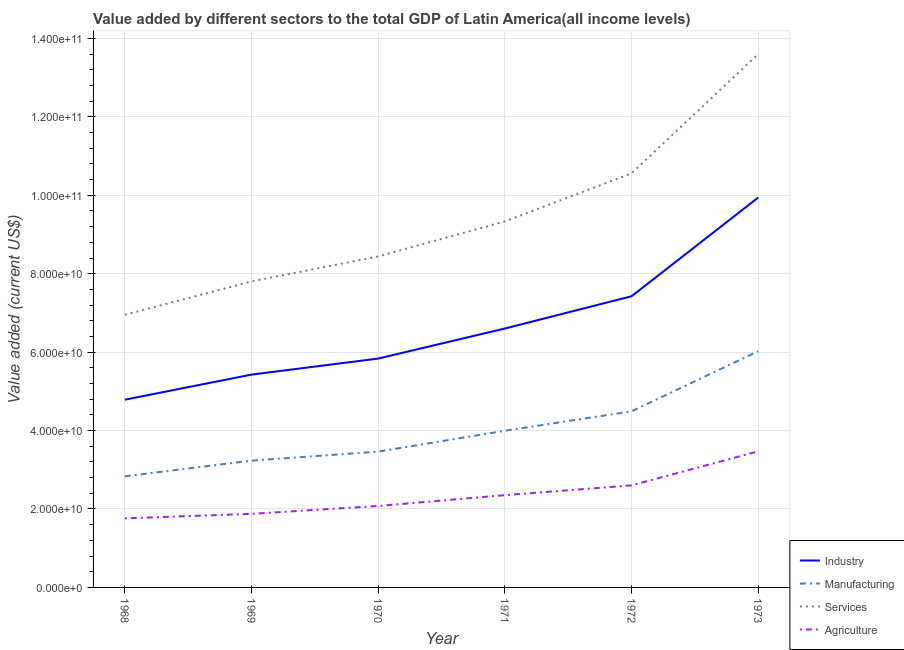How many different coloured lines are there?
Make the answer very short. 4. What is the value added by manufacturing sector in 1972?
Your answer should be very brief. 4.49e+1. Across all years, what is the maximum value added by services sector?
Provide a succinct answer. 1.36e+11. Across all years, what is the minimum value added by manufacturing sector?
Make the answer very short. 2.83e+1. In which year was the value added by agricultural sector minimum?
Make the answer very short. 1968. What is the total value added by services sector in the graph?
Ensure brevity in your answer.  5.67e+11. What is the difference between the value added by industrial sector in 1969 and that in 1971?
Provide a short and direct response. -1.18e+1. What is the difference between the value added by industrial sector in 1971 and the value added by services sector in 1970?
Make the answer very short. -1.84e+1. What is the average value added by manufacturing sector per year?
Make the answer very short. 4.01e+1. In the year 1970, what is the difference between the value added by agricultural sector and value added by manufacturing sector?
Offer a terse response. -1.39e+1. In how many years, is the value added by services sector greater than 88000000000 US$?
Your answer should be compact. 3. What is the ratio of the value added by manufacturing sector in 1968 to that in 1971?
Provide a short and direct response. 0.71. Is the value added by services sector in 1972 less than that in 1973?
Offer a very short reply. Yes. Is the difference between the value added by industrial sector in 1972 and 1973 greater than the difference between the value added by services sector in 1972 and 1973?
Provide a succinct answer. Yes. What is the difference between the highest and the second highest value added by manufacturing sector?
Make the answer very short. 1.53e+1. What is the difference between the highest and the lowest value added by agricultural sector?
Provide a succinct answer. 1.71e+1. In how many years, is the value added by manufacturing sector greater than the average value added by manufacturing sector taken over all years?
Ensure brevity in your answer.  2. Is the sum of the value added by manufacturing sector in 1971 and 1973 greater than the maximum value added by agricultural sector across all years?
Provide a short and direct response. Yes. Is it the case that in every year, the sum of the value added by services sector and value added by manufacturing sector is greater than the sum of value added by agricultural sector and value added by industrial sector?
Provide a short and direct response. No. Does the value added by manufacturing sector monotonically increase over the years?
Make the answer very short. Yes. How many years are there in the graph?
Offer a very short reply. 6. How many legend labels are there?
Provide a succinct answer. 4. What is the title of the graph?
Keep it short and to the point. Value added by different sectors to the total GDP of Latin America(all income levels). What is the label or title of the X-axis?
Provide a succinct answer. Year. What is the label or title of the Y-axis?
Your answer should be very brief. Value added (current US$). What is the Value added (current US$) in Industry in 1968?
Ensure brevity in your answer.  4.79e+1. What is the Value added (current US$) of Manufacturing in 1968?
Offer a very short reply. 2.83e+1. What is the Value added (current US$) in Services in 1968?
Provide a succinct answer. 6.95e+1. What is the Value added (current US$) of Agriculture in 1968?
Keep it short and to the point. 1.76e+1. What is the Value added (current US$) in Industry in 1969?
Your answer should be very brief. 5.43e+1. What is the Value added (current US$) in Manufacturing in 1969?
Provide a succinct answer. 3.23e+1. What is the Value added (current US$) in Services in 1969?
Provide a succinct answer. 7.80e+1. What is the Value added (current US$) in Agriculture in 1969?
Give a very brief answer. 1.88e+1. What is the Value added (current US$) in Industry in 1970?
Your response must be concise. 5.84e+1. What is the Value added (current US$) in Manufacturing in 1970?
Keep it short and to the point. 3.46e+1. What is the Value added (current US$) of Services in 1970?
Provide a short and direct response. 8.44e+1. What is the Value added (current US$) in Agriculture in 1970?
Provide a short and direct response. 2.08e+1. What is the Value added (current US$) of Industry in 1971?
Give a very brief answer. 6.60e+1. What is the Value added (current US$) in Manufacturing in 1971?
Provide a short and direct response. 3.99e+1. What is the Value added (current US$) of Services in 1971?
Your answer should be compact. 9.33e+1. What is the Value added (current US$) in Agriculture in 1971?
Make the answer very short. 2.35e+1. What is the Value added (current US$) in Industry in 1972?
Your response must be concise. 7.42e+1. What is the Value added (current US$) of Manufacturing in 1972?
Offer a terse response. 4.49e+1. What is the Value added (current US$) of Services in 1972?
Provide a short and direct response. 1.06e+11. What is the Value added (current US$) in Agriculture in 1972?
Offer a very short reply. 2.60e+1. What is the Value added (current US$) in Industry in 1973?
Give a very brief answer. 9.94e+1. What is the Value added (current US$) in Manufacturing in 1973?
Your answer should be very brief. 6.02e+1. What is the Value added (current US$) of Services in 1973?
Your answer should be compact. 1.36e+11. What is the Value added (current US$) of Agriculture in 1973?
Ensure brevity in your answer.  3.47e+1. Across all years, what is the maximum Value added (current US$) in Industry?
Your response must be concise. 9.94e+1. Across all years, what is the maximum Value added (current US$) of Manufacturing?
Keep it short and to the point. 6.02e+1. Across all years, what is the maximum Value added (current US$) of Services?
Your answer should be very brief. 1.36e+11. Across all years, what is the maximum Value added (current US$) in Agriculture?
Give a very brief answer. 3.47e+1. Across all years, what is the minimum Value added (current US$) of Industry?
Offer a terse response. 4.79e+1. Across all years, what is the minimum Value added (current US$) of Manufacturing?
Ensure brevity in your answer.  2.83e+1. Across all years, what is the minimum Value added (current US$) in Services?
Your response must be concise. 6.95e+1. Across all years, what is the minimum Value added (current US$) of Agriculture?
Provide a succinct answer. 1.76e+1. What is the total Value added (current US$) in Industry in the graph?
Your answer should be very brief. 4.00e+11. What is the total Value added (current US$) in Manufacturing in the graph?
Your response must be concise. 2.40e+11. What is the total Value added (current US$) of Services in the graph?
Offer a very short reply. 5.67e+11. What is the total Value added (current US$) of Agriculture in the graph?
Your answer should be compact. 1.41e+11. What is the difference between the Value added (current US$) in Industry in 1968 and that in 1969?
Give a very brief answer. -6.40e+09. What is the difference between the Value added (current US$) in Manufacturing in 1968 and that in 1969?
Give a very brief answer. -4.00e+09. What is the difference between the Value added (current US$) in Services in 1968 and that in 1969?
Offer a terse response. -8.50e+09. What is the difference between the Value added (current US$) of Agriculture in 1968 and that in 1969?
Make the answer very short. -1.15e+09. What is the difference between the Value added (current US$) in Industry in 1968 and that in 1970?
Ensure brevity in your answer.  -1.05e+1. What is the difference between the Value added (current US$) in Manufacturing in 1968 and that in 1970?
Give a very brief answer. -6.30e+09. What is the difference between the Value added (current US$) of Services in 1968 and that in 1970?
Keep it short and to the point. -1.49e+1. What is the difference between the Value added (current US$) in Agriculture in 1968 and that in 1970?
Your answer should be compact. -3.16e+09. What is the difference between the Value added (current US$) in Industry in 1968 and that in 1971?
Your answer should be compact. -1.82e+1. What is the difference between the Value added (current US$) in Manufacturing in 1968 and that in 1971?
Give a very brief answer. -1.16e+1. What is the difference between the Value added (current US$) of Services in 1968 and that in 1971?
Provide a short and direct response. -2.38e+1. What is the difference between the Value added (current US$) of Agriculture in 1968 and that in 1971?
Give a very brief answer. -5.92e+09. What is the difference between the Value added (current US$) in Industry in 1968 and that in 1972?
Keep it short and to the point. -2.64e+1. What is the difference between the Value added (current US$) of Manufacturing in 1968 and that in 1972?
Your response must be concise. -1.66e+1. What is the difference between the Value added (current US$) of Services in 1968 and that in 1972?
Ensure brevity in your answer.  -3.61e+1. What is the difference between the Value added (current US$) of Agriculture in 1968 and that in 1972?
Make the answer very short. -8.41e+09. What is the difference between the Value added (current US$) in Industry in 1968 and that in 1973?
Keep it short and to the point. -5.16e+1. What is the difference between the Value added (current US$) of Manufacturing in 1968 and that in 1973?
Make the answer very short. -3.19e+1. What is the difference between the Value added (current US$) of Services in 1968 and that in 1973?
Your answer should be very brief. -6.65e+1. What is the difference between the Value added (current US$) of Agriculture in 1968 and that in 1973?
Give a very brief answer. -1.71e+1. What is the difference between the Value added (current US$) in Industry in 1969 and that in 1970?
Keep it short and to the point. -4.09e+09. What is the difference between the Value added (current US$) of Manufacturing in 1969 and that in 1970?
Your answer should be compact. -2.30e+09. What is the difference between the Value added (current US$) in Services in 1969 and that in 1970?
Make the answer very short. -6.38e+09. What is the difference between the Value added (current US$) in Agriculture in 1969 and that in 1970?
Your answer should be compact. -2.01e+09. What is the difference between the Value added (current US$) in Industry in 1969 and that in 1971?
Your response must be concise. -1.18e+1. What is the difference between the Value added (current US$) of Manufacturing in 1969 and that in 1971?
Your answer should be very brief. -7.61e+09. What is the difference between the Value added (current US$) in Services in 1969 and that in 1971?
Your response must be concise. -1.53e+1. What is the difference between the Value added (current US$) of Agriculture in 1969 and that in 1971?
Provide a succinct answer. -4.77e+09. What is the difference between the Value added (current US$) of Industry in 1969 and that in 1972?
Keep it short and to the point. -2.00e+1. What is the difference between the Value added (current US$) of Manufacturing in 1969 and that in 1972?
Keep it short and to the point. -1.26e+1. What is the difference between the Value added (current US$) in Services in 1969 and that in 1972?
Ensure brevity in your answer.  -2.76e+1. What is the difference between the Value added (current US$) of Agriculture in 1969 and that in 1972?
Your answer should be compact. -7.26e+09. What is the difference between the Value added (current US$) in Industry in 1969 and that in 1973?
Ensure brevity in your answer.  -4.52e+1. What is the difference between the Value added (current US$) in Manufacturing in 1969 and that in 1973?
Your response must be concise. -2.79e+1. What is the difference between the Value added (current US$) of Services in 1969 and that in 1973?
Provide a short and direct response. -5.80e+1. What is the difference between the Value added (current US$) in Agriculture in 1969 and that in 1973?
Provide a succinct answer. -1.59e+1. What is the difference between the Value added (current US$) of Industry in 1970 and that in 1971?
Keep it short and to the point. -7.67e+09. What is the difference between the Value added (current US$) of Manufacturing in 1970 and that in 1971?
Your response must be concise. -5.32e+09. What is the difference between the Value added (current US$) of Services in 1970 and that in 1971?
Give a very brief answer. -8.93e+09. What is the difference between the Value added (current US$) in Agriculture in 1970 and that in 1971?
Give a very brief answer. -2.76e+09. What is the difference between the Value added (current US$) in Industry in 1970 and that in 1972?
Ensure brevity in your answer.  -1.59e+1. What is the difference between the Value added (current US$) of Manufacturing in 1970 and that in 1972?
Make the answer very short. -1.03e+1. What is the difference between the Value added (current US$) in Services in 1970 and that in 1972?
Ensure brevity in your answer.  -2.12e+1. What is the difference between the Value added (current US$) in Agriculture in 1970 and that in 1972?
Offer a terse response. -5.25e+09. What is the difference between the Value added (current US$) of Industry in 1970 and that in 1973?
Offer a very short reply. -4.11e+1. What is the difference between the Value added (current US$) in Manufacturing in 1970 and that in 1973?
Keep it short and to the point. -2.56e+1. What is the difference between the Value added (current US$) in Services in 1970 and that in 1973?
Your answer should be very brief. -5.16e+1. What is the difference between the Value added (current US$) in Agriculture in 1970 and that in 1973?
Your answer should be very brief. -1.39e+1. What is the difference between the Value added (current US$) of Industry in 1971 and that in 1972?
Your response must be concise. -8.22e+09. What is the difference between the Value added (current US$) of Manufacturing in 1971 and that in 1972?
Ensure brevity in your answer.  -4.96e+09. What is the difference between the Value added (current US$) of Services in 1971 and that in 1972?
Make the answer very short. -1.23e+1. What is the difference between the Value added (current US$) in Agriculture in 1971 and that in 1972?
Your response must be concise. -2.50e+09. What is the difference between the Value added (current US$) in Industry in 1971 and that in 1973?
Offer a very short reply. -3.34e+1. What is the difference between the Value added (current US$) in Manufacturing in 1971 and that in 1973?
Your answer should be very brief. -2.03e+1. What is the difference between the Value added (current US$) of Services in 1971 and that in 1973?
Offer a very short reply. -4.27e+1. What is the difference between the Value added (current US$) of Agriculture in 1971 and that in 1973?
Your answer should be compact. -1.12e+1. What is the difference between the Value added (current US$) in Industry in 1972 and that in 1973?
Your response must be concise. -2.52e+1. What is the difference between the Value added (current US$) in Manufacturing in 1972 and that in 1973?
Provide a short and direct response. -1.53e+1. What is the difference between the Value added (current US$) of Services in 1972 and that in 1973?
Provide a short and direct response. -3.04e+1. What is the difference between the Value added (current US$) of Agriculture in 1972 and that in 1973?
Your answer should be compact. -8.68e+09. What is the difference between the Value added (current US$) in Industry in 1968 and the Value added (current US$) in Manufacturing in 1969?
Keep it short and to the point. 1.55e+1. What is the difference between the Value added (current US$) in Industry in 1968 and the Value added (current US$) in Services in 1969?
Give a very brief answer. -3.02e+1. What is the difference between the Value added (current US$) of Industry in 1968 and the Value added (current US$) of Agriculture in 1969?
Provide a succinct answer. 2.91e+1. What is the difference between the Value added (current US$) of Manufacturing in 1968 and the Value added (current US$) of Services in 1969?
Your answer should be compact. -4.97e+1. What is the difference between the Value added (current US$) in Manufacturing in 1968 and the Value added (current US$) in Agriculture in 1969?
Your response must be concise. 9.57e+09. What is the difference between the Value added (current US$) in Services in 1968 and the Value added (current US$) in Agriculture in 1969?
Your response must be concise. 5.08e+1. What is the difference between the Value added (current US$) of Industry in 1968 and the Value added (current US$) of Manufacturing in 1970?
Your answer should be compact. 1.32e+1. What is the difference between the Value added (current US$) of Industry in 1968 and the Value added (current US$) of Services in 1970?
Your answer should be very brief. -3.65e+1. What is the difference between the Value added (current US$) of Industry in 1968 and the Value added (current US$) of Agriculture in 1970?
Ensure brevity in your answer.  2.71e+1. What is the difference between the Value added (current US$) in Manufacturing in 1968 and the Value added (current US$) in Services in 1970?
Provide a short and direct response. -5.61e+1. What is the difference between the Value added (current US$) of Manufacturing in 1968 and the Value added (current US$) of Agriculture in 1970?
Your response must be concise. 7.56e+09. What is the difference between the Value added (current US$) in Services in 1968 and the Value added (current US$) in Agriculture in 1970?
Provide a short and direct response. 4.88e+1. What is the difference between the Value added (current US$) of Industry in 1968 and the Value added (current US$) of Manufacturing in 1971?
Ensure brevity in your answer.  7.92e+09. What is the difference between the Value added (current US$) in Industry in 1968 and the Value added (current US$) in Services in 1971?
Provide a succinct answer. -4.55e+1. What is the difference between the Value added (current US$) in Industry in 1968 and the Value added (current US$) in Agriculture in 1971?
Offer a terse response. 2.43e+1. What is the difference between the Value added (current US$) in Manufacturing in 1968 and the Value added (current US$) in Services in 1971?
Give a very brief answer. -6.50e+1. What is the difference between the Value added (current US$) of Manufacturing in 1968 and the Value added (current US$) of Agriculture in 1971?
Offer a very short reply. 4.80e+09. What is the difference between the Value added (current US$) in Services in 1968 and the Value added (current US$) in Agriculture in 1971?
Make the answer very short. 4.60e+1. What is the difference between the Value added (current US$) of Industry in 1968 and the Value added (current US$) of Manufacturing in 1972?
Keep it short and to the point. 2.96e+09. What is the difference between the Value added (current US$) in Industry in 1968 and the Value added (current US$) in Services in 1972?
Provide a succinct answer. -5.77e+1. What is the difference between the Value added (current US$) in Industry in 1968 and the Value added (current US$) in Agriculture in 1972?
Keep it short and to the point. 2.18e+1. What is the difference between the Value added (current US$) of Manufacturing in 1968 and the Value added (current US$) of Services in 1972?
Offer a very short reply. -7.73e+1. What is the difference between the Value added (current US$) in Manufacturing in 1968 and the Value added (current US$) in Agriculture in 1972?
Provide a succinct answer. 2.31e+09. What is the difference between the Value added (current US$) in Services in 1968 and the Value added (current US$) in Agriculture in 1972?
Provide a short and direct response. 4.35e+1. What is the difference between the Value added (current US$) of Industry in 1968 and the Value added (current US$) of Manufacturing in 1973?
Offer a terse response. -1.24e+1. What is the difference between the Value added (current US$) of Industry in 1968 and the Value added (current US$) of Services in 1973?
Your answer should be very brief. -8.81e+1. What is the difference between the Value added (current US$) of Industry in 1968 and the Value added (current US$) of Agriculture in 1973?
Your answer should be compact. 1.32e+1. What is the difference between the Value added (current US$) in Manufacturing in 1968 and the Value added (current US$) in Services in 1973?
Ensure brevity in your answer.  -1.08e+11. What is the difference between the Value added (current US$) in Manufacturing in 1968 and the Value added (current US$) in Agriculture in 1973?
Offer a very short reply. -6.38e+09. What is the difference between the Value added (current US$) of Services in 1968 and the Value added (current US$) of Agriculture in 1973?
Offer a very short reply. 3.48e+1. What is the difference between the Value added (current US$) in Industry in 1969 and the Value added (current US$) in Manufacturing in 1970?
Your answer should be compact. 1.96e+1. What is the difference between the Value added (current US$) in Industry in 1969 and the Value added (current US$) in Services in 1970?
Offer a terse response. -3.01e+1. What is the difference between the Value added (current US$) in Industry in 1969 and the Value added (current US$) in Agriculture in 1970?
Your answer should be very brief. 3.35e+1. What is the difference between the Value added (current US$) in Manufacturing in 1969 and the Value added (current US$) in Services in 1970?
Give a very brief answer. -5.21e+1. What is the difference between the Value added (current US$) of Manufacturing in 1969 and the Value added (current US$) of Agriculture in 1970?
Your answer should be very brief. 1.16e+1. What is the difference between the Value added (current US$) of Services in 1969 and the Value added (current US$) of Agriculture in 1970?
Keep it short and to the point. 5.73e+1. What is the difference between the Value added (current US$) of Industry in 1969 and the Value added (current US$) of Manufacturing in 1971?
Your response must be concise. 1.43e+1. What is the difference between the Value added (current US$) of Industry in 1969 and the Value added (current US$) of Services in 1971?
Offer a terse response. -3.91e+1. What is the difference between the Value added (current US$) in Industry in 1969 and the Value added (current US$) in Agriculture in 1971?
Offer a very short reply. 3.07e+1. What is the difference between the Value added (current US$) of Manufacturing in 1969 and the Value added (current US$) of Services in 1971?
Offer a very short reply. -6.10e+1. What is the difference between the Value added (current US$) of Manufacturing in 1969 and the Value added (current US$) of Agriculture in 1971?
Provide a succinct answer. 8.80e+09. What is the difference between the Value added (current US$) of Services in 1969 and the Value added (current US$) of Agriculture in 1971?
Make the answer very short. 5.45e+1. What is the difference between the Value added (current US$) of Industry in 1969 and the Value added (current US$) of Manufacturing in 1972?
Keep it short and to the point. 9.36e+09. What is the difference between the Value added (current US$) of Industry in 1969 and the Value added (current US$) of Services in 1972?
Your answer should be very brief. -5.13e+1. What is the difference between the Value added (current US$) in Industry in 1969 and the Value added (current US$) in Agriculture in 1972?
Offer a terse response. 2.82e+1. What is the difference between the Value added (current US$) of Manufacturing in 1969 and the Value added (current US$) of Services in 1972?
Make the answer very short. -7.33e+1. What is the difference between the Value added (current US$) of Manufacturing in 1969 and the Value added (current US$) of Agriculture in 1972?
Your answer should be compact. 6.31e+09. What is the difference between the Value added (current US$) of Services in 1969 and the Value added (current US$) of Agriculture in 1972?
Ensure brevity in your answer.  5.20e+1. What is the difference between the Value added (current US$) of Industry in 1969 and the Value added (current US$) of Manufacturing in 1973?
Your answer should be very brief. -5.96e+09. What is the difference between the Value added (current US$) of Industry in 1969 and the Value added (current US$) of Services in 1973?
Offer a very short reply. -8.17e+1. What is the difference between the Value added (current US$) in Industry in 1969 and the Value added (current US$) in Agriculture in 1973?
Offer a terse response. 1.96e+1. What is the difference between the Value added (current US$) of Manufacturing in 1969 and the Value added (current US$) of Services in 1973?
Give a very brief answer. -1.04e+11. What is the difference between the Value added (current US$) in Manufacturing in 1969 and the Value added (current US$) in Agriculture in 1973?
Your answer should be very brief. -2.37e+09. What is the difference between the Value added (current US$) of Services in 1969 and the Value added (current US$) of Agriculture in 1973?
Your answer should be compact. 4.33e+1. What is the difference between the Value added (current US$) in Industry in 1970 and the Value added (current US$) in Manufacturing in 1971?
Offer a terse response. 1.84e+1. What is the difference between the Value added (current US$) of Industry in 1970 and the Value added (current US$) of Services in 1971?
Give a very brief answer. -3.50e+1. What is the difference between the Value added (current US$) in Industry in 1970 and the Value added (current US$) in Agriculture in 1971?
Offer a very short reply. 3.48e+1. What is the difference between the Value added (current US$) of Manufacturing in 1970 and the Value added (current US$) of Services in 1971?
Make the answer very short. -5.87e+1. What is the difference between the Value added (current US$) of Manufacturing in 1970 and the Value added (current US$) of Agriculture in 1971?
Keep it short and to the point. 1.11e+1. What is the difference between the Value added (current US$) of Services in 1970 and the Value added (current US$) of Agriculture in 1971?
Your answer should be compact. 6.09e+1. What is the difference between the Value added (current US$) in Industry in 1970 and the Value added (current US$) in Manufacturing in 1972?
Give a very brief answer. 1.34e+1. What is the difference between the Value added (current US$) in Industry in 1970 and the Value added (current US$) in Services in 1972?
Provide a succinct answer. -4.72e+1. What is the difference between the Value added (current US$) of Industry in 1970 and the Value added (current US$) of Agriculture in 1972?
Your answer should be compact. 3.23e+1. What is the difference between the Value added (current US$) of Manufacturing in 1970 and the Value added (current US$) of Services in 1972?
Provide a short and direct response. -7.10e+1. What is the difference between the Value added (current US$) of Manufacturing in 1970 and the Value added (current US$) of Agriculture in 1972?
Ensure brevity in your answer.  8.61e+09. What is the difference between the Value added (current US$) in Services in 1970 and the Value added (current US$) in Agriculture in 1972?
Your response must be concise. 5.84e+1. What is the difference between the Value added (current US$) of Industry in 1970 and the Value added (current US$) of Manufacturing in 1973?
Your answer should be compact. -1.88e+09. What is the difference between the Value added (current US$) in Industry in 1970 and the Value added (current US$) in Services in 1973?
Give a very brief answer. -7.77e+1. What is the difference between the Value added (current US$) in Industry in 1970 and the Value added (current US$) in Agriculture in 1973?
Your answer should be compact. 2.37e+1. What is the difference between the Value added (current US$) of Manufacturing in 1970 and the Value added (current US$) of Services in 1973?
Ensure brevity in your answer.  -1.01e+11. What is the difference between the Value added (current US$) in Manufacturing in 1970 and the Value added (current US$) in Agriculture in 1973?
Your response must be concise. -7.51e+07. What is the difference between the Value added (current US$) of Services in 1970 and the Value added (current US$) of Agriculture in 1973?
Offer a terse response. 4.97e+1. What is the difference between the Value added (current US$) in Industry in 1971 and the Value added (current US$) in Manufacturing in 1972?
Your answer should be compact. 2.11e+1. What is the difference between the Value added (current US$) of Industry in 1971 and the Value added (current US$) of Services in 1972?
Your response must be concise. -3.96e+1. What is the difference between the Value added (current US$) of Industry in 1971 and the Value added (current US$) of Agriculture in 1972?
Offer a very short reply. 4.00e+1. What is the difference between the Value added (current US$) in Manufacturing in 1971 and the Value added (current US$) in Services in 1972?
Your answer should be compact. -6.56e+1. What is the difference between the Value added (current US$) in Manufacturing in 1971 and the Value added (current US$) in Agriculture in 1972?
Provide a succinct answer. 1.39e+1. What is the difference between the Value added (current US$) of Services in 1971 and the Value added (current US$) of Agriculture in 1972?
Offer a terse response. 6.73e+1. What is the difference between the Value added (current US$) of Industry in 1971 and the Value added (current US$) of Manufacturing in 1973?
Offer a terse response. 5.79e+09. What is the difference between the Value added (current US$) in Industry in 1971 and the Value added (current US$) in Services in 1973?
Your answer should be compact. -7.00e+1. What is the difference between the Value added (current US$) of Industry in 1971 and the Value added (current US$) of Agriculture in 1973?
Provide a succinct answer. 3.13e+1. What is the difference between the Value added (current US$) of Manufacturing in 1971 and the Value added (current US$) of Services in 1973?
Your response must be concise. -9.61e+1. What is the difference between the Value added (current US$) in Manufacturing in 1971 and the Value added (current US$) in Agriculture in 1973?
Make the answer very short. 5.24e+09. What is the difference between the Value added (current US$) in Services in 1971 and the Value added (current US$) in Agriculture in 1973?
Provide a succinct answer. 5.86e+1. What is the difference between the Value added (current US$) in Industry in 1972 and the Value added (current US$) in Manufacturing in 1973?
Your response must be concise. 1.40e+1. What is the difference between the Value added (current US$) in Industry in 1972 and the Value added (current US$) in Services in 1973?
Offer a very short reply. -6.18e+1. What is the difference between the Value added (current US$) in Industry in 1972 and the Value added (current US$) in Agriculture in 1973?
Your response must be concise. 3.95e+1. What is the difference between the Value added (current US$) in Manufacturing in 1972 and the Value added (current US$) in Services in 1973?
Offer a terse response. -9.11e+1. What is the difference between the Value added (current US$) in Manufacturing in 1972 and the Value added (current US$) in Agriculture in 1973?
Give a very brief answer. 1.02e+1. What is the difference between the Value added (current US$) of Services in 1972 and the Value added (current US$) of Agriculture in 1973?
Give a very brief answer. 7.09e+1. What is the average Value added (current US$) in Industry per year?
Give a very brief answer. 6.67e+1. What is the average Value added (current US$) in Manufacturing per year?
Ensure brevity in your answer.  4.01e+1. What is the average Value added (current US$) of Services per year?
Give a very brief answer. 9.45e+1. What is the average Value added (current US$) in Agriculture per year?
Your answer should be very brief. 2.36e+1. In the year 1968, what is the difference between the Value added (current US$) in Industry and Value added (current US$) in Manufacturing?
Provide a succinct answer. 1.95e+1. In the year 1968, what is the difference between the Value added (current US$) of Industry and Value added (current US$) of Services?
Provide a short and direct response. -2.17e+1. In the year 1968, what is the difference between the Value added (current US$) of Industry and Value added (current US$) of Agriculture?
Offer a very short reply. 3.03e+1. In the year 1968, what is the difference between the Value added (current US$) in Manufacturing and Value added (current US$) in Services?
Your answer should be very brief. -4.12e+1. In the year 1968, what is the difference between the Value added (current US$) of Manufacturing and Value added (current US$) of Agriculture?
Your answer should be very brief. 1.07e+1. In the year 1968, what is the difference between the Value added (current US$) in Services and Value added (current US$) in Agriculture?
Keep it short and to the point. 5.19e+1. In the year 1969, what is the difference between the Value added (current US$) in Industry and Value added (current US$) in Manufacturing?
Your response must be concise. 2.19e+1. In the year 1969, what is the difference between the Value added (current US$) in Industry and Value added (current US$) in Services?
Give a very brief answer. -2.38e+1. In the year 1969, what is the difference between the Value added (current US$) of Industry and Value added (current US$) of Agriculture?
Give a very brief answer. 3.55e+1. In the year 1969, what is the difference between the Value added (current US$) in Manufacturing and Value added (current US$) in Services?
Your answer should be compact. -4.57e+1. In the year 1969, what is the difference between the Value added (current US$) in Manufacturing and Value added (current US$) in Agriculture?
Provide a short and direct response. 1.36e+1. In the year 1969, what is the difference between the Value added (current US$) in Services and Value added (current US$) in Agriculture?
Offer a terse response. 5.93e+1. In the year 1970, what is the difference between the Value added (current US$) of Industry and Value added (current US$) of Manufacturing?
Ensure brevity in your answer.  2.37e+1. In the year 1970, what is the difference between the Value added (current US$) of Industry and Value added (current US$) of Services?
Give a very brief answer. -2.60e+1. In the year 1970, what is the difference between the Value added (current US$) in Industry and Value added (current US$) in Agriculture?
Ensure brevity in your answer.  3.76e+1. In the year 1970, what is the difference between the Value added (current US$) in Manufacturing and Value added (current US$) in Services?
Make the answer very short. -4.98e+1. In the year 1970, what is the difference between the Value added (current US$) of Manufacturing and Value added (current US$) of Agriculture?
Make the answer very short. 1.39e+1. In the year 1970, what is the difference between the Value added (current US$) of Services and Value added (current US$) of Agriculture?
Make the answer very short. 6.36e+1. In the year 1971, what is the difference between the Value added (current US$) in Industry and Value added (current US$) in Manufacturing?
Provide a short and direct response. 2.61e+1. In the year 1971, what is the difference between the Value added (current US$) in Industry and Value added (current US$) in Services?
Offer a terse response. -2.73e+1. In the year 1971, what is the difference between the Value added (current US$) in Industry and Value added (current US$) in Agriculture?
Make the answer very short. 4.25e+1. In the year 1971, what is the difference between the Value added (current US$) in Manufacturing and Value added (current US$) in Services?
Give a very brief answer. -5.34e+1. In the year 1971, what is the difference between the Value added (current US$) of Manufacturing and Value added (current US$) of Agriculture?
Offer a terse response. 1.64e+1. In the year 1971, what is the difference between the Value added (current US$) in Services and Value added (current US$) in Agriculture?
Provide a succinct answer. 6.98e+1. In the year 1972, what is the difference between the Value added (current US$) in Industry and Value added (current US$) in Manufacturing?
Your answer should be very brief. 2.93e+1. In the year 1972, what is the difference between the Value added (current US$) of Industry and Value added (current US$) of Services?
Provide a succinct answer. -3.13e+1. In the year 1972, what is the difference between the Value added (current US$) of Industry and Value added (current US$) of Agriculture?
Make the answer very short. 4.82e+1. In the year 1972, what is the difference between the Value added (current US$) of Manufacturing and Value added (current US$) of Services?
Offer a terse response. -6.07e+1. In the year 1972, what is the difference between the Value added (current US$) of Manufacturing and Value added (current US$) of Agriculture?
Offer a terse response. 1.89e+1. In the year 1972, what is the difference between the Value added (current US$) in Services and Value added (current US$) in Agriculture?
Offer a terse response. 7.96e+1. In the year 1973, what is the difference between the Value added (current US$) in Industry and Value added (current US$) in Manufacturing?
Your response must be concise. 3.92e+1. In the year 1973, what is the difference between the Value added (current US$) in Industry and Value added (current US$) in Services?
Provide a short and direct response. -3.66e+1. In the year 1973, what is the difference between the Value added (current US$) of Industry and Value added (current US$) of Agriculture?
Your answer should be compact. 6.47e+1. In the year 1973, what is the difference between the Value added (current US$) in Manufacturing and Value added (current US$) in Services?
Keep it short and to the point. -7.58e+1. In the year 1973, what is the difference between the Value added (current US$) of Manufacturing and Value added (current US$) of Agriculture?
Offer a terse response. 2.55e+1. In the year 1973, what is the difference between the Value added (current US$) in Services and Value added (current US$) in Agriculture?
Your response must be concise. 1.01e+11. What is the ratio of the Value added (current US$) of Industry in 1968 to that in 1969?
Your response must be concise. 0.88. What is the ratio of the Value added (current US$) of Manufacturing in 1968 to that in 1969?
Your response must be concise. 0.88. What is the ratio of the Value added (current US$) of Services in 1968 to that in 1969?
Make the answer very short. 0.89. What is the ratio of the Value added (current US$) in Agriculture in 1968 to that in 1969?
Your answer should be compact. 0.94. What is the ratio of the Value added (current US$) in Industry in 1968 to that in 1970?
Provide a short and direct response. 0.82. What is the ratio of the Value added (current US$) of Manufacturing in 1968 to that in 1970?
Ensure brevity in your answer.  0.82. What is the ratio of the Value added (current US$) of Services in 1968 to that in 1970?
Ensure brevity in your answer.  0.82. What is the ratio of the Value added (current US$) of Agriculture in 1968 to that in 1970?
Ensure brevity in your answer.  0.85. What is the ratio of the Value added (current US$) in Industry in 1968 to that in 1971?
Offer a very short reply. 0.72. What is the ratio of the Value added (current US$) in Manufacturing in 1968 to that in 1971?
Ensure brevity in your answer.  0.71. What is the ratio of the Value added (current US$) of Services in 1968 to that in 1971?
Make the answer very short. 0.74. What is the ratio of the Value added (current US$) of Agriculture in 1968 to that in 1971?
Your response must be concise. 0.75. What is the ratio of the Value added (current US$) of Industry in 1968 to that in 1972?
Provide a succinct answer. 0.64. What is the ratio of the Value added (current US$) of Manufacturing in 1968 to that in 1972?
Keep it short and to the point. 0.63. What is the ratio of the Value added (current US$) of Services in 1968 to that in 1972?
Your response must be concise. 0.66. What is the ratio of the Value added (current US$) in Agriculture in 1968 to that in 1972?
Offer a very short reply. 0.68. What is the ratio of the Value added (current US$) of Industry in 1968 to that in 1973?
Keep it short and to the point. 0.48. What is the ratio of the Value added (current US$) in Manufacturing in 1968 to that in 1973?
Provide a succinct answer. 0.47. What is the ratio of the Value added (current US$) of Services in 1968 to that in 1973?
Your response must be concise. 0.51. What is the ratio of the Value added (current US$) of Agriculture in 1968 to that in 1973?
Keep it short and to the point. 0.51. What is the ratio of the Value added (current US$) in Industry in 1969 to that in 1970?
Your answer should be very brief. 0.93. What is the ratio of the Value added (current US$) of Manufacturing in 1969 to that in 1970?
Provide a short and direct response. 0.93. What is the ratio of the Value added (current US$) of Services in 1969 to that in 1970?
Your response must be concise. 0.92. What is the ratio of the Value added (current US$) of Agriculture in 1969 to that in 1970?
Offer a very short reply. 0.9. What is the ratio of the Value added (current US$) of Industry in 1969 to that in 1971?
Your response must be concise. 0.82. What is the ratio of the Value added (current US$) in Manufacturing in 1969 to that in 1971?
Provide a short and direct response. 0.81. What is the ratio of the Value added (current US$) in Services in 1969 to that in 1971?
Keep it short and to the point. 0.84. What is the ratio of the Value added (current US$) in Agriculture in 1969 to that in 1971?
Offer a terse response. 0.8. What is the ratio of the Value added (current US$) of Industry in 1969 to that in 1972?
Give a very brief answer. 0.73. What is the ratio of the Value added (current US$) of Manufacturing in 1969 to that in 1972?
Offer a terse response. 0.72. What is the ratio of the Value added (current US$) of Services in 1969 to that in 1972?
Provide a short and direct response. 0.74. What is the ratio of the Value added (current US$) in Agriculture in 1969 to that in 1972?
Your answer should be very brief. 0.72. What is the ratio of the Value added (current US$) of Industry in 1969 to that in 1973?
Offer a terse response. 0.55. What is the ratio of the Value added (current US$) of Manufacturing in 1969 to that in 1973?
Give a very brief answer. 0.54. What is the ratio of the Value added (current US$) of Services in 1969 to that in 1973?
Ensure brevity in your answer.  0.57. What is the ratio of the Value added (current US$) of Agriculture in 1969 to that in 1973?
Make the answer very short. 0.54. What is the ratio of the Value added (current US$) in Industry in 1970 to that in 1971?
Your answer should be compact. 0.88. What is the ratio of the Value added (current US$) of Manufacturing in 1970 to that in 1971?
Provide a short and direct response. 0.87. What is the ratio of the Value added (current US$) of Services in 1970 to that in 1971?
Your answer should be very brief. 0.9. What is the ratio of the Value added (current US$) of Agriculture in 1970 to that in 1971?
Make the answer very short. 0.88. What is the ratio of the Value added (current US$) in Industry in 1970 to that in 1972?
Offer a very short reply. 0.79. What is the ratio of the Value added (current US$) of Manufacturing in 1970 to that in 1972?
Provide a short and direct response. 0.77. What is the ratio of the Value added (current US$) in Services in 1970 to that in 1972?
Provide a succinct answer. 0.8. What is the ratio of the Value added (current US$) in Agriculture in 1970 to that in 1972?
Offer a very short reply. 0.8. What is the ratio of the Value added (current US$) of Industry in 1970 to that in 1973?
Ensure brevity in your answer.  0.59. What is the ratio of the Value added (current US$) in Manufacturing in 1970 to that in 1973?
Provide a succinct answer. 0.57. What is the ratio of the Value added (current US$) of Services in 1970 to that in 1973?
Give a very brief answer. 0.62. What is the ratio of the Value added (current US$) in Agriculture in 1970 to that in 1973?
Offer a very short reply. 0.6. What is the ratio of the Value added (current US$) of Industry in 1971 to that in 1972?
Ensure brevity in your answer.  0.89. What is the ratio of the Value added (current US$) of Manufacturing in 1971 to that in 1972?
Provide a short and direct response. 0.89. What is the ratio of the Value added (current US$) of Services in 1971 to that in 1972?
Ensure brevity in your answer.  0.88. What is the ratio of the Value added (current US$) in Agriculture in 1971 to that in 1972?
Provide a succinct answer. 0.9. What is the ratio of the Value added (current US$) in Industry in 1971 to that in 1973?
Give a very brief answer. 0.66. What is the ratio of the Value added (current US$) of Manufacturing in 1971 to that in 1973?
Give a very brief answer. 0.66. What is the ratio of the Value added (current US$) in Services in 1971 to that in 1973?
Offer a very short reply. 0.69. What is the ratio of the Value added (current US$) in Agriculture in 1971 to that in 1973?
Ensure brevity in your answer.  0.68. What is the ratio of the Value added (current US$) in Industry in 1972 to that in 1973?
Give a very brief answer. 0.75. What is the ratio of the Value added (current US$) of Manufacturing in 1972 to that in 1973?
Ensure brevity in your answer.  0.75. What is the ratio of the Value added (current US$) in Services in 1972 to that in 1973?
Offer a terse response. 0.78. What is the ratio of the Value added (current US$) of Agriculture in 1972 to that in 1973?
Your answer should be compact. 0.75. What is the difference between the highest and the second highest Value added (current US$) of Industry?
Make the answer very short. 2.52e+1. What is the difference between the highest and the second highest Value added (current US$) of Manufacturing?
Make the answer very short. 1.53e+1. What is the difference between the highest and the second highest Value added (current US$) in Services?
Provide a short and direct response. 3.04e+1. What is the difference between the highest and the second highest Value added (current US$) of Agriculture?
Give a very brief answer. 8.68e+09. What is the difference between the highest and the lowest Value added (current US$) in Industry?
Your response must be concise. 5.16e+1. What is the difference between the highest and the lowest Value added (current US$) of Manufacturing?
Keep it short and to the point. 3.19e+1. What is the difference between the highest and the lowest Value added (current US$) of Services?
Offer a very short reply. 6.65e+1. What is the difference between the highest and the lowest Value added (current US$) of Agriculture?
Give a very brief answer. 1.71e+1. 